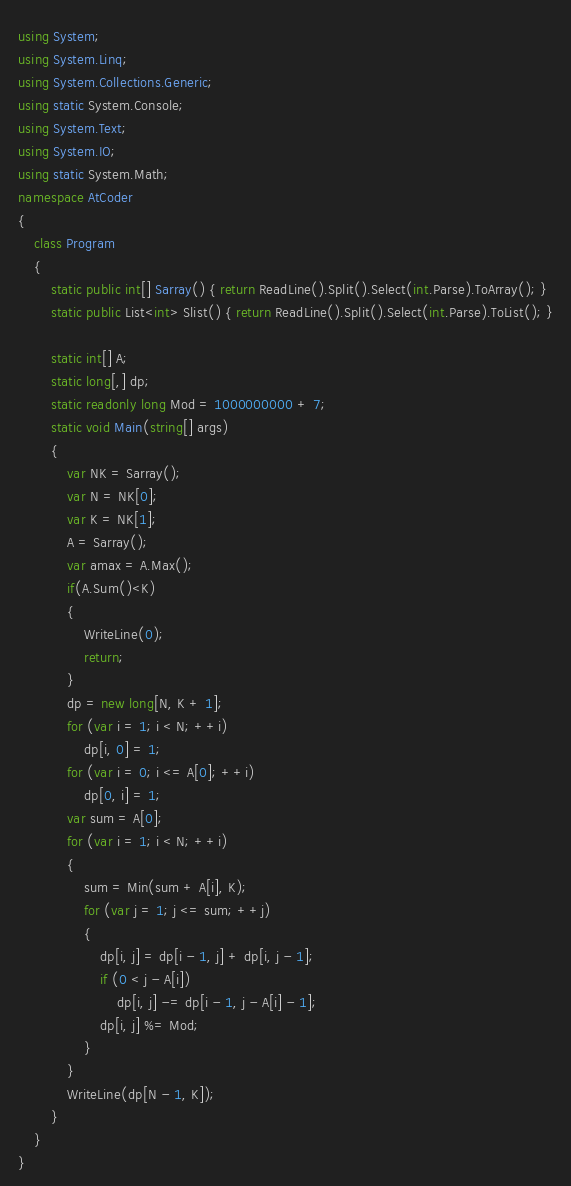Convert code to text. <code><loc_0><loc_0><loc_500><loc_500><_C#_>using System;
using System.Linq;
using System.Collections.Generic;
using static System.Console;
using System.Text;
using System.IO;
using static System.Math;
namespace AtCoder
{
    class Program
    {
        static public int[] Sarray() { return ReadLine().Split().Select(int.Parse).ToArray(); }
        static public List<int> Slist() { return ReadLine().Split().Select(int.Parse).ToList(); }

        static int[] A;
        static long[,] dp;
        static readonly long Mod = 1000000000 + 7;
        static void Main(string[] args)
        {
            var NK = Sarray();
            var N = NK[0];
            var K = NK[1];
            A = Sarray();
            var amax = A.Max();
            if(A.Sum()<K)
            {
                WriteLine(0);
                return;
            }
            dp = new long[N, K + 1];
            for (var i = 1; i < N; ++i)
                dp[i, 0] = 1;
            for (var i = 0; i <= A[0]; ++i)
                dp[0, i] = 1;
            var sum = A[0];
            for (var i = 1; i < N; ++i)
            {
                sum = Min(sum + A[i], K);
                for (var j = 1; j <= sum; ++j)
                {
                    dp[i, j] = dp[i - 1, j] + dp[i, j - 1];
                    if (0 < j - A[i])
                        dp[i, j] -= dp[i - 1, j - A[i] - 1];
                    dp[i, j] %= Mod;
                }
            }
            WriteLine(dp[N - 1, K]);
        }
    }
}</code> 